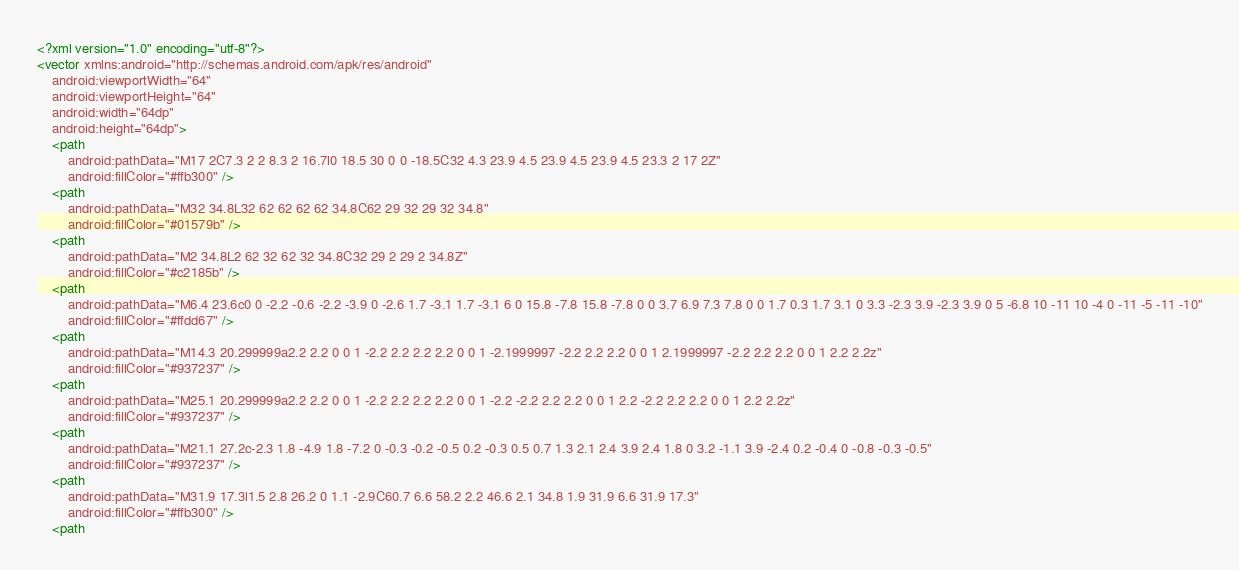Convert code to text. <code><loc_0><loc_0><loc_500><loc_500><_XML_><?xml version="1.0" encoding="utf-8"?>
<vector xmlns:android="http://schemas.android.com/apk/res/android"
    android:viewportWidth="64"
    android:viewportHeight="64"
    android:width="64dp"
    android:height="64dp">
    <path
        android:pathData="M17 2C7.3 2 2 8.3 2 16.7l0 18.5 30 0 0 -18.5C32 4.3 23.9 4.5 23.9 4.5 23.9 4.5 23.3 2 17 2Z"
        android:fillColor="#ffb300" />
    <path
        android:pathData="M32 34.8L32 62 62 62 62 34.8C62 29 32 29 32 34.8"
        android:fillColor="#01579b" />
    <path
        android:pathData="M2 34.8L2 62 32 62 32 34.8C32 29 2 29 2 34.8Z"
        android:fillColor="#c2185b" />
    <path
        android:pathData="M6.4 23.6c0 0 -2.2 -0.6 -2.2 -3.9 0 -2.6 1.7 -3.1 1.7 -3.1 6 0 15.8 -7.8 15.8 -7.8 0 0 3.7 6.9 7.3 7.8 0 0 1.7 0.3 1.7 3.1 0 3.3 -2.3 3.9 -2.3 3.9 0 5 -6.8 10 -11 10 -4 0 -11 -5 -11 -10"
        android:fillColor="#ffdd67" />
    <path
        android:pathData="M14.3 20.299999a2.2 2.2 0 0 1 -2.2 2.2 2.2 2.2 0 0 1 -2.1999997 -2.2 2.2 2.2 0 0 1 2.1999997 -2.2 2.2 2.2 0 0 1 2.2 2.2z"
        android:fillColor="#937237" />
    <path
        android:pathData="M25.1 20.299999a2.2 2.2 0 0 1 -2.2 2.2 2.2 2.2 0 0 1 -2.2 -2.2 2.2 2.2 0 0 1 2.2 -2.2 2.2 2.2 0 0 1 2.2 2.2z"
        android:fillColor="#937237" />
    <path
        android:pathData="M21.1 27.2c-2.3 1.8 -4.9 1.8 -7.2 0 -0.3 -0.2 -0.5 0.2 -0.3 0.5 0.7 1.3 2.1 2.4 3.9 2.4 1.8 0 3.2 -1.1 3.9 -2.4 0.2 -0.4 0 -0.8 -0.3 -0.5"
        android:fillColor="#937237" />
    <path
        android:pathData="M31.9 17.3l1.5 2.8 26.2 0 1.1 -2.9C60.7 6.6 58.2 2.2 46.6 2.1 34.8 1.9 31.9 6.6 31.9 17.3"
        android:fillColor="#ffb300" />
    <path</code> 